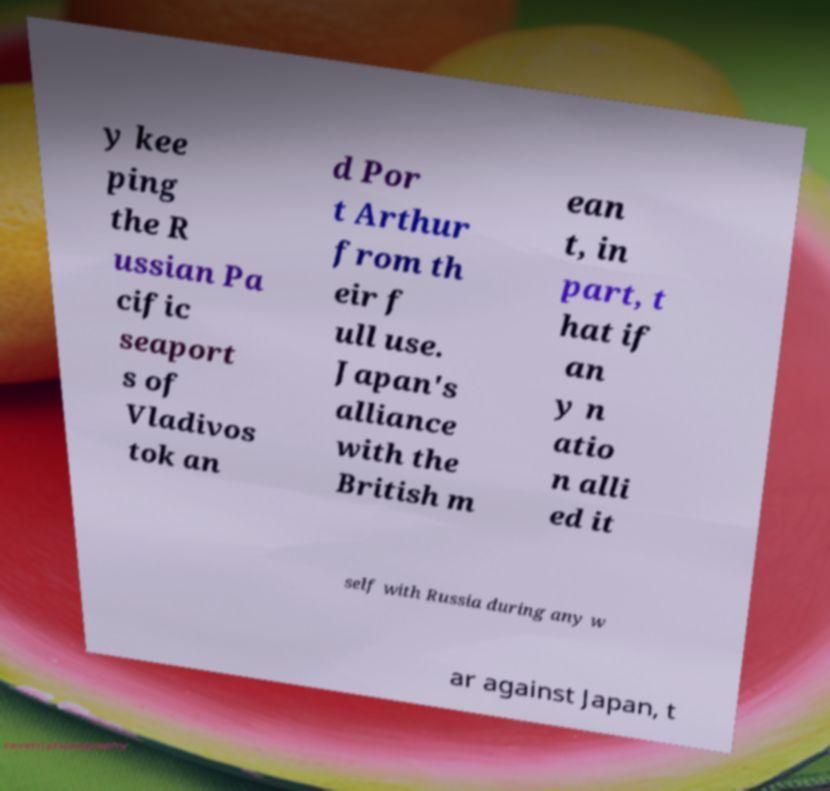For documentation purposes, I need the text within this image transcribed. Could you provide that? y kee ping the R ussian Pa cific seaport s of Vladivos tok an d Por t Arthur from th eir f ull use. Japan's alliance with the British m ean t, in part, t hat if an y n atio n alli ed it self with Russia during any w ar against Japan, t 